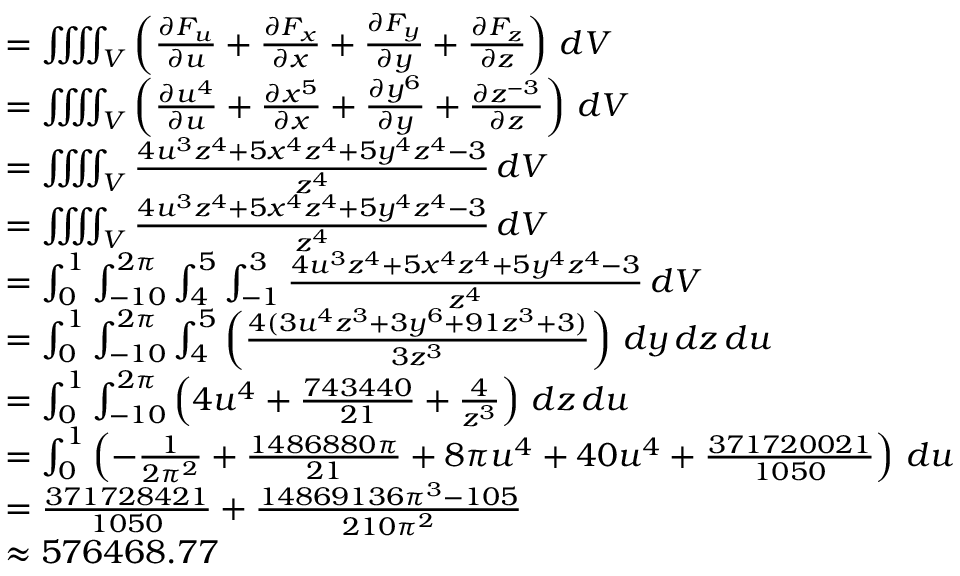Convert formula to latex. <formula><loc_0><loc_0><loc_500><loc_500>{ \begin{array} { r l } & { = \i i i i n t _ { V } \left ( { \frac { \partial F _ { u } } { \partial u } } + { \frac { \partial F _ { x } } { \partial x } } + { \frac { \partial F _ { y } } { \partial y } } + { \frac { \partial F _ { z } } { \partial z } } \right ) \, d V } \\ & { = \i i i i n t _ { V } \left ( { \frac { \partial u ^ { 4 } } { \partial u } } + { \frac { \partial x ^ { 5 } } { \partial x } } + { \frac { \partial y ^ { 6 } } { \partial y } } + { \frac { \partial z ^ { - 3 } } { \partial z } } \right ) \, d V } \\ & { = \i i i i n t _ { V } { \frac { 4 u ^ { 3 } z ^ { 4 } + 5 x ^ { 4 } z ^ { 4 } + 5 y ^ { 4 } z ^ { 4 } - 3 } { z ^ { 4 } } } \, d V } \\ & { = \i i i i n t _ { V } { \frac { 4 u ^ { 3 } z ^ { 4 } + 5 x ^ { 4 } z ^ { 4 } + 5 y ^ { 4 } z ^ { 4 } - 3 } { z ^ { 4 } } } \, d V } \\ & { = \int _ { 0 } ^ { 1 } \int _ { - 1 0 } ^ { 2 \pi } \int _ { 4 } ^ { 5 } \int _ { - 1 } ^ { 3 } { \frac { 4 u ^ { 3 } z ^ { 4 } + 5 x ^ { 4 } z ^ { 4 } + 5 y ^ { 4 } z ^ { 4 } - 3 } { z ^ { 4 } } } \, d V } \\ & { = \int _ { 0 } ^ { 1 } \int _ { - 1 0 } ^ { 2 \pi } \int _ { 4 } ^ { 5 } \left ( { \frac { 4 ( 3 u ^ { 4 } z ^ { 3 } + 3 y ^ { 6 } + 9 1 z ^ { 3 } + 3 ) } { 3 z ^ { 3 } } } \right ) \, d y \, d z \, d u } \\ & { = \int _ { 0 } ^ { 1 } \int _ { - 1 0 } ^ { 2 \pi } \left ( 4 u ^ { 4 } + { \frac { 7 4 3 4 4 0 } { 2 1 } } + { \frac { 4 } { z ^ { 3 } } } \right ) \, d z \, d u } \\ & { = \int _ { 0 } ^ { 1 } \left ( - { \frac { 1 } { 2 \pi ^ { 2 } } } + { \frac { 1 4 8 6 8 8 0 \pi } { 2 1 } } + 8 \pi u ^ { 4 } + 4 0 u ^ { 4 } + { \frac { 3 7 1 7 2 0 0 2 1 } { 1 0 5 0 } } \right ) \, d u } \\ & { = { \frac { 3 7 1 7 2 8 4 2 1 } { 1 0 5 0 } } + { \frac { 1 4 8 6 9 1 3 6 \pi ^ { 3 } - 1 0 5 } { 2 1 0 \pi ^ { 2 } } } } \\ & { \approx { 5 7 6 4 6 8 . 7 7 } } \end{array} }</formula> 